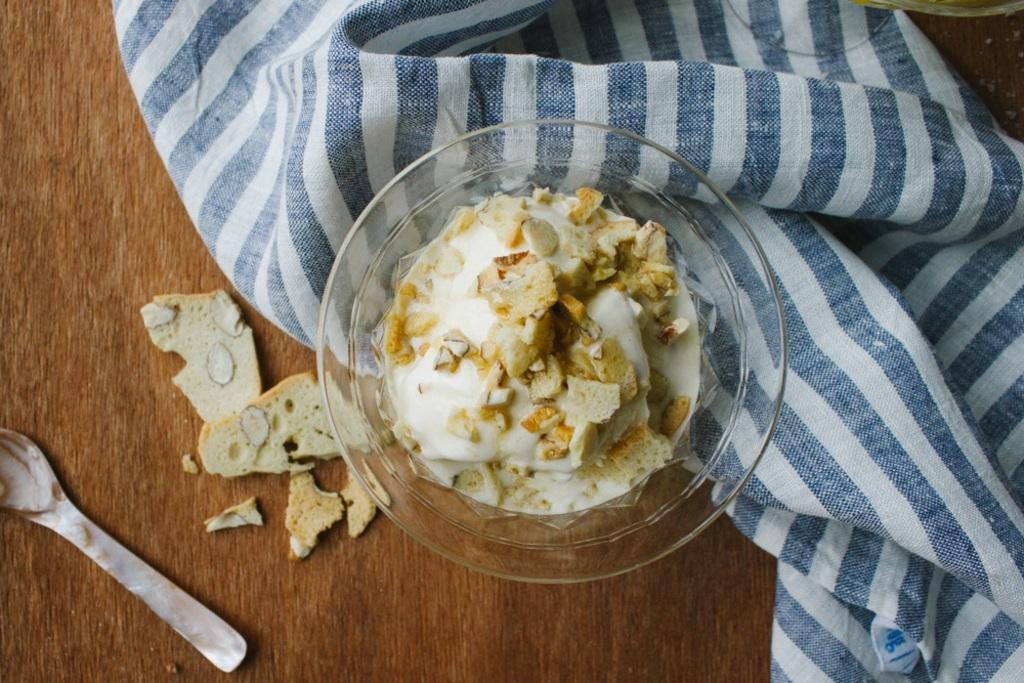What type of food is shown in the image? The food is presented in a bowl, but the specific type of food is not mentioned in the facts. How is the food arranged in the image? The food is presented in a bowl. What is the purpose of the cloth in the image? The purpose of the cloth is not mentioned in the facts. What utensil is visible in the image? There is a spoon in the image. What type of fruit is shown in the image? There is no fruit present in the image; only food in a bowl, a cloth, and a spoon are mentioned. 